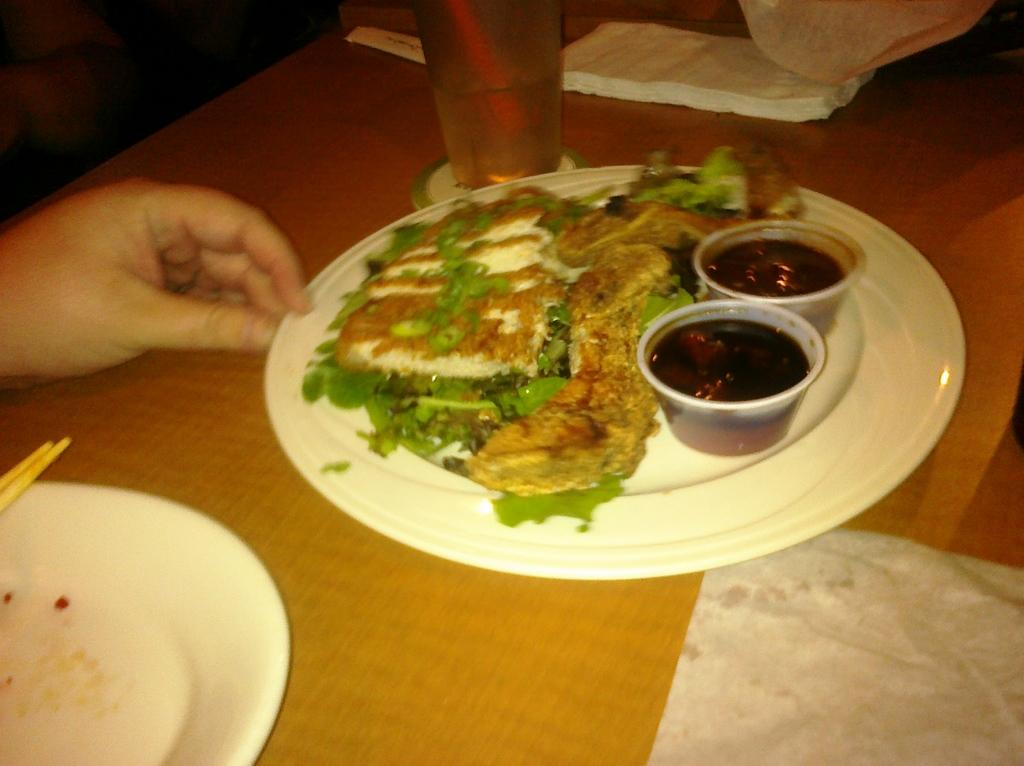What is located in the foreground of the image? In the foreground of the image, there is a tissue, a platter, chopsticks, a platter with food, two cups, and a glass. What is the person's hand doing in the foreground of the image? The person's hand is visible in the foreground of the image, but its action cannot be determined from the provided facts. Where are the tissues located in the image? The tissues are located at the top of the image. What type of plastic material is covering the food on the platter? There is no plastic material covering the food on the platter in the image. How many flies are visible on the person's hand in the image? There are no flies visible in the image, and the person's hand is not interacting with any flies. What color is the scarf worn by the person in the image? There is no person wearing a scarf in the image. 